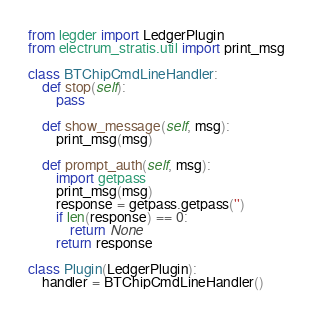<code> <loc_0><loc_0><loc_500><loc_500><_Python_>from legder import LedgerPlugin
from electrum_stratis.util import print_msg

class BTChipCmdLineHandler:
    def stop(self):
        pass

    def show_message(self, msg):
        print_msg(msg)

    def prompt_auth(self, msg):
        import getpass
        print_msg(msg)
        response = getpass.getpass('')
        if len(response) == 0:
            return None
        return response

class Plugin(LedgerPlugin):
    handler = BTChipCmdLineHandler()
</code> 